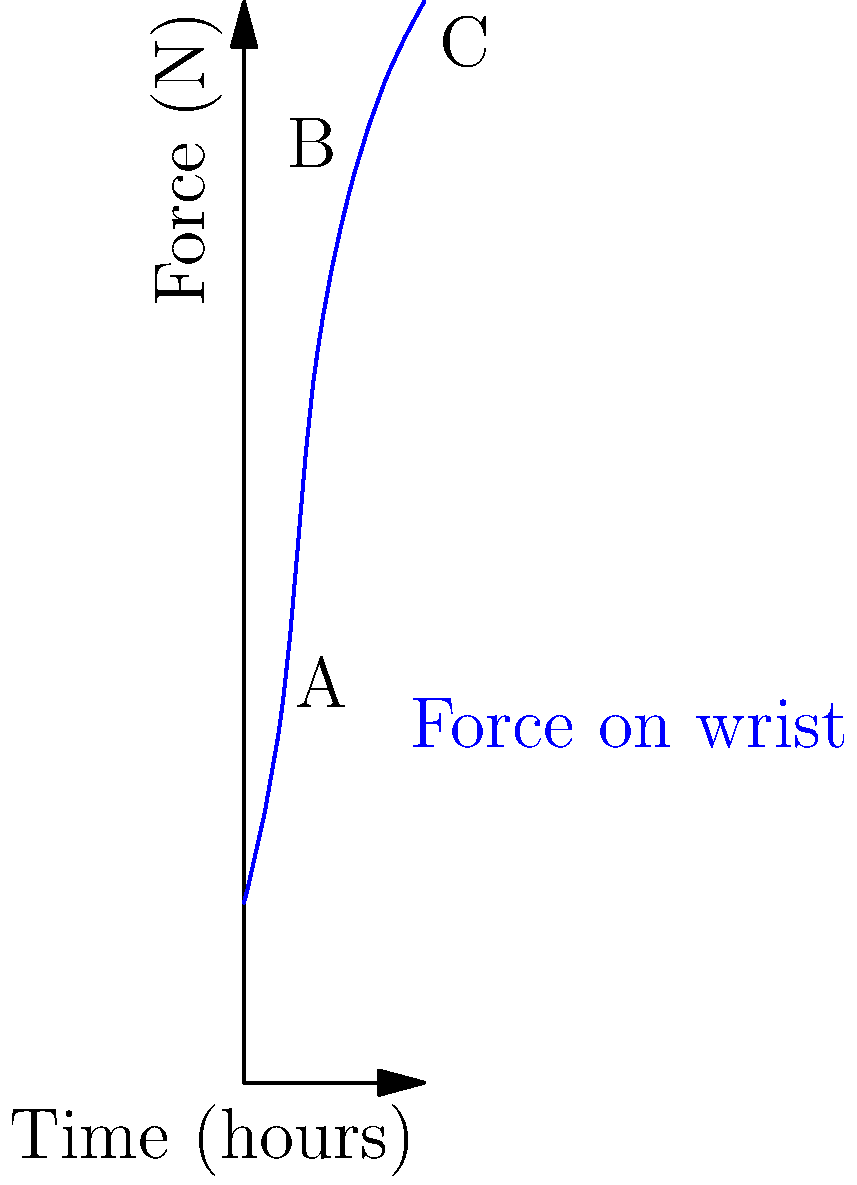The graph shows the biomechanical force acting on a translator's wrist during an extended typing session. If the translator takes a 30-minute break after every 3 hours of work, what is the approximate reduction in force (in Newtons) experienced by the wrist immediately after the break, assuming they return to the force level at the 1-hour mark? To solve this problem, we need to follow these steps:

1. Identify the force at the 3-hour mark (point B on the graph):
   At 3 hours, the force is approximately 25 N.

2. Identify the force at the 1-hour mark (point A on the graph):
   At 1 hour, the force is approximately 10 N.

3. Calculate the difference between these two forces:
   $$\text{Force reduction} = \text{Force at 3 hours} - \text{Force at 1 hour}$$
   $$\text{Force reduction} = 25 \text{ N} - 10 \text{ N} = 15 \text{ N}$$

This 15 N reduction represents the approximate decrease in force experienced by the translator's wrist immediately after taking a 30-minute break and returning to work at the force level equivalent to the 1-hour mark.
Answer: 15 N 